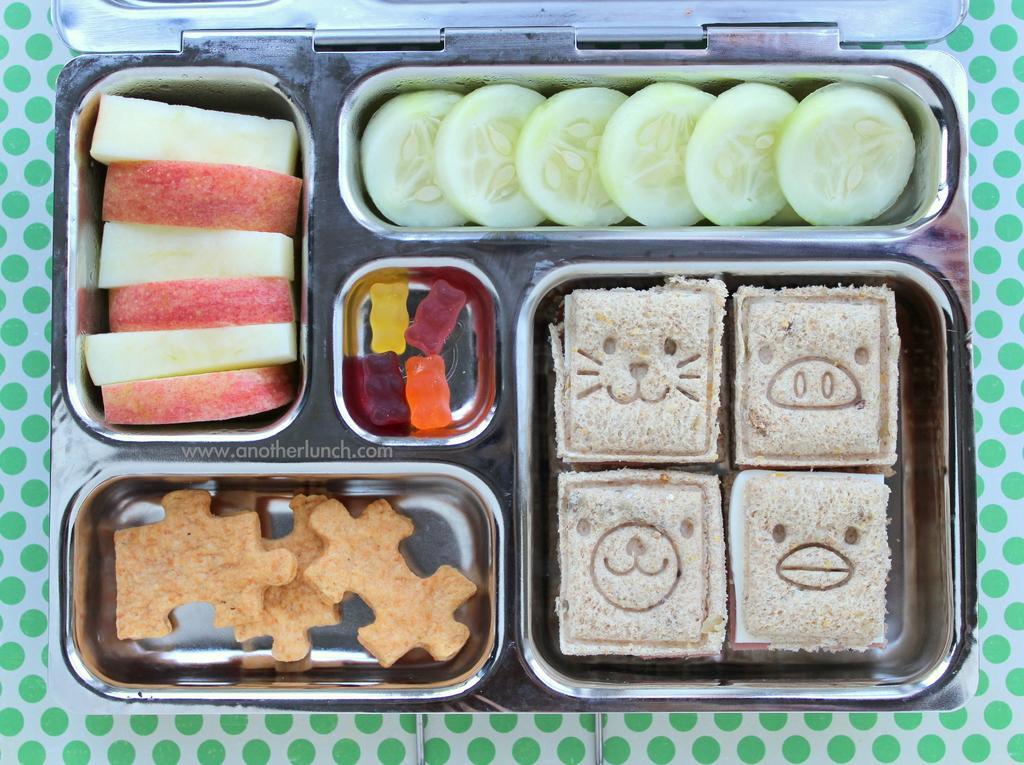Can you describe this image briefly? In this picture there is a table, on the table there is a box. In the box there are cakes, vegetables, lollies and biscuits. 